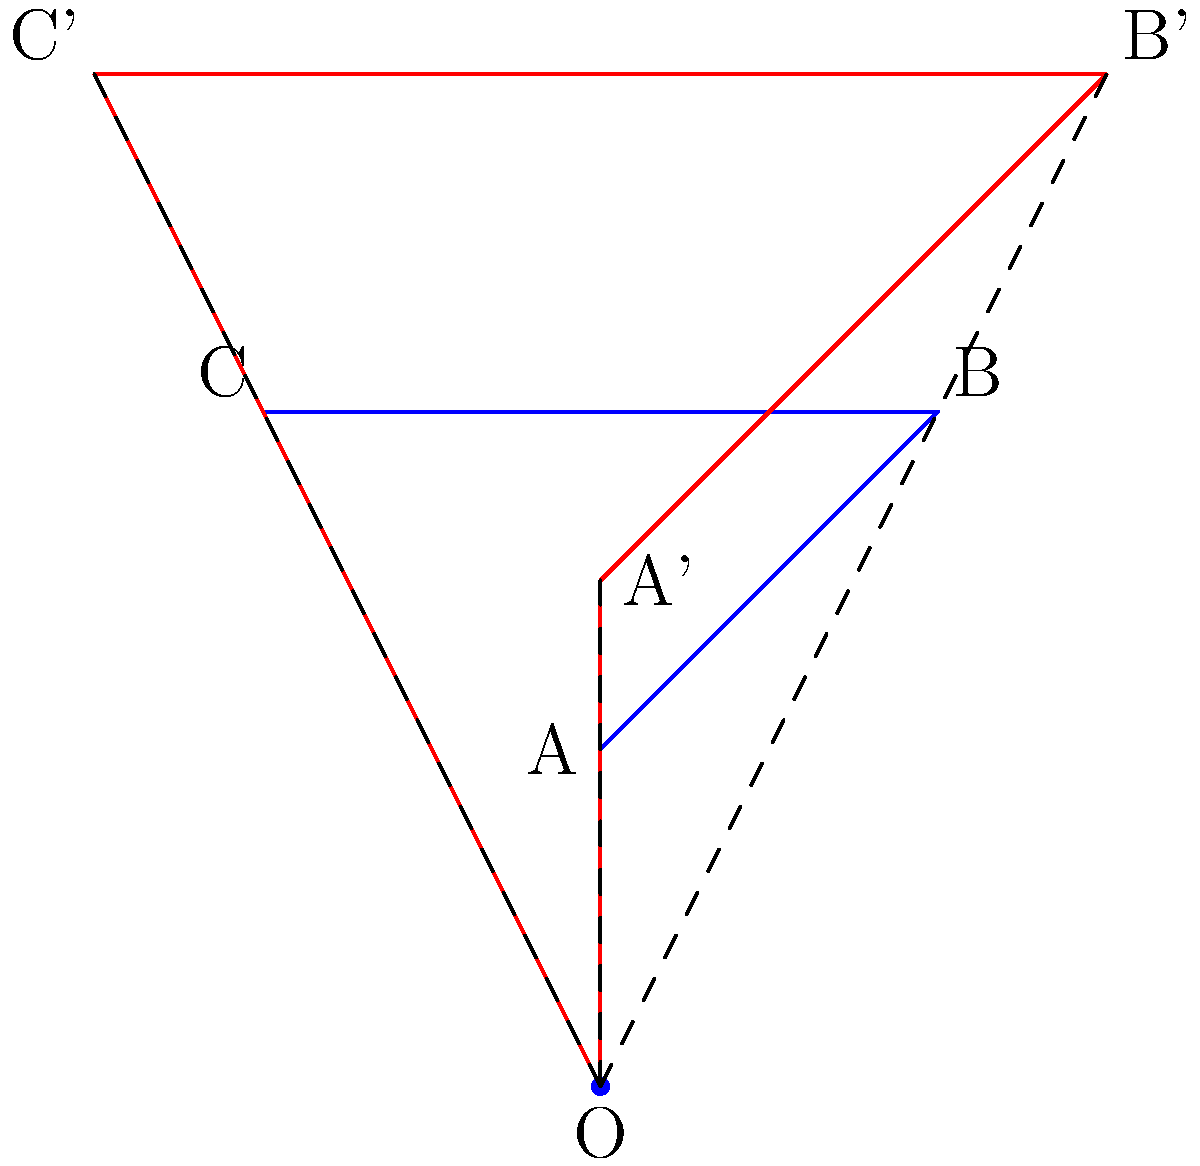The Setzer family tree diagram has been dilated from point O with a scale factor of 1.5. If the original distance from point O to point A was 4 inches, what is the new distance from point O to point A' in the dilated diagram? To solve this problem, we need to understand the concept of dilation and how it affects distances from the center point. Let's break it down step-by-step:

1. Dilation is a transformation that enlarges or shrinks a figure by a scale factor from a fixed point (center of dilation).

2. In this case:
   - The center of dilation is point O
   - The scale factor is 1.5
   - The original distance from O to A is 4 inches

3. When a figure is dilated, all distances from the center of dilation are multiplied by the scale factor.

4. To find the new distance from O to A', we multiply the original distance by the scale factor:

   $$ \text{New distance} = \text{Original distance} \times \text{Scale factor} $$
   $$ \text{OA'} = \text{OA} \times 1.5 $$
   $$ \text{OA'} = 4 \text{ inches} \times 1.5 $$
   $$ \text{OA'} = 6 \text{ inches} $$

Therefore, the new distance from point O to point A' in the dilated diagram is 6 inches.
Answer: 6 inches 